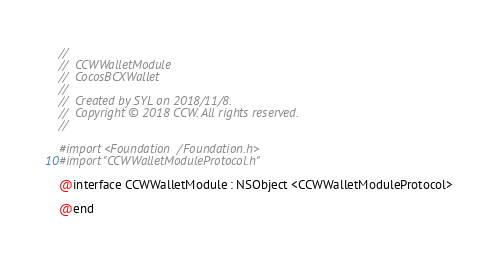Convert code to text. <code><loc_0><loc_0><loc_500><loc_500><_C_>//
//  CCWWalletModule
//  CocosBCXWallet
//
//  Created by SYL on 2018/11/8.
//  Copyright © 2018 CCW. All rights reserved.
//

#import <Foundation/Foundation.h>
#import "CCWWalletModuleProtocol.h"

@interface CCWWalletModule : NSObject <CCWWalletModuleProtocol>

@end
</code> 